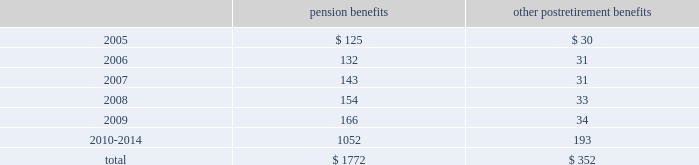Notes to consolidated financial statements ( continued ) 17 .
Pension plans and postretirement health care and life insurance benefit plans ( continued ) benefit payments the table sets forth amounts of benefits expected to be paid over the next ten years from the company 2019s pension and postretirement plans as of december 31 , 2004: .
18 .
Stock compensation plans on may 18 , 2000 , the shareholders of the hartford approved the hartford incentive stock plan ( the 201c2000 plan 201d ) , which replaced the hartford 1995 incentive stock plan ( the 201c1995 plan 201d ) .
The terms of the 2000 plan were substantially similar to the terms of the 1995 plan except that the 1995 plan had an annual award limit and a higher maximum award limit .
Under the 2000 plan , awards may be granted in the form of non-qualified or incentive stock options qualifying under section 422a of the internal revenue code , performance shares or restricted stock , or any combination of the foregoing .
In addition , stock appreciation rights may be granted in connection with all or part of any stock options granted under the 2000 plan .
In december 2004 , the 2000 plan was amended to allow for grants of restricted stock units effective as of january 1 , 2005 .
The aggregate number of shares of stock , which may be awarded , is subject to a maximum limit of 17211837 shares applicable to all awards for the ten-year duration of the 2000 plan .
All options granted have an exercise price equal to the market price of the company 2019s common stock on the date of grant , and an option 2019s maximum term is ten years and two days .
Certain options become exercisable over a three year period commencing one year from the date of grant , while certain other options become exercisable upon the attainment of specified market price appreciation of the company 2019s common shares .
For any year , no individual employee may receive an award of options for more than 1000000 shares .
As of december 31 , 2004 , the hartford had not issued any incentive stock options under the 2000 plan .
Performance awards of common stock granted under the 2000 plan become payable upon the attainment of specific performance goals achieved over a period of not less than one nor more than five years , and the restricted stock granted is subject to a restriction period .
On a cumulative basis , no more than 20% ( 20 % ) of the aggregate number of shares which may be awarded under the 2000 plan are available for performance shares and restricted stock awards .
Also , the maximum award of performance shares for any individual employee in any year is 200000 shares .
In 2004 , 2003 and 2002 , the company granted shares of common stock of 315452 , 333712 and 40852 with weighted average prices of $ 64.93 , $ 38.13 and $ 62.28 , respectively , related to performance share and restricted stock awards .
In 1996 , the company established the hartford employee stock purchase plan ( 201cespp 201d ) .
Under this plan , eligible employees of the hartford may purchase common stock of the company at a 15% ( 15 % ) discount from the lower of the closing market price at the beginning or end of the quarterly offering period .
The company may sell up to 5400000 shares of stock to eligible employees under the espp .
In 2004 , 2003 and 2002 , 345262 , 443467 and 408304 shares were sold , respectively .
The per share weighted average fair value of the discount under the espp was $ 9.31 , $ 11.96 , and $ 11.70 in 2004 , 2003 and 2002 , respectively .
Additionally , during 1997 , the hartford established employee stock purchase plans for certain employees of the company 2019s international subsidiaries .
Under these plans , participants may purchase common stock of the hartford at a fixed price at the end of a three-year period .
The activity under these programs is not material. .
What portion of the total expected payment for benefits is related to pension benefits? 
Computations: (1772 / (1772 + 352))
Answer: 0.83427. 